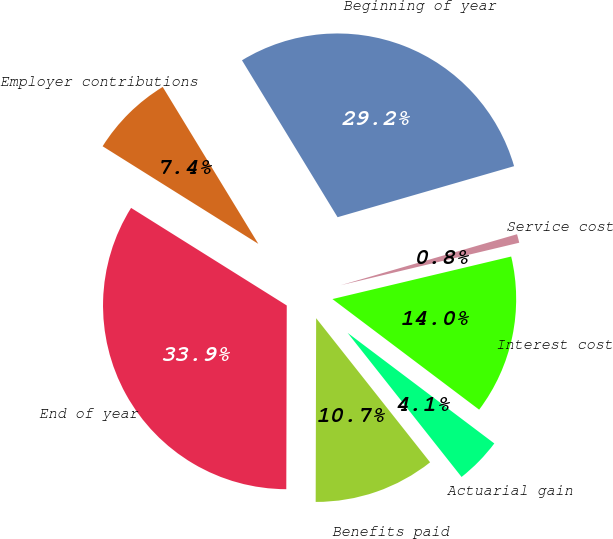<chart> <loc_0><loc_0><loc_500><loc_500><pie_chart><fcel>Beginning of year<fcel>Service cost<fcel>Interest cost<fcel>Actuarial gain<fcel>Benefits paid<fcel>End of year<fcel>Employer contributions<nl><fcel>29.23%<fcel>0.76%<fcel>14.0%<fcel>4.07%<fcel>10.69%<fcel>33.87%<fcel>7.38%<nl></chart> 